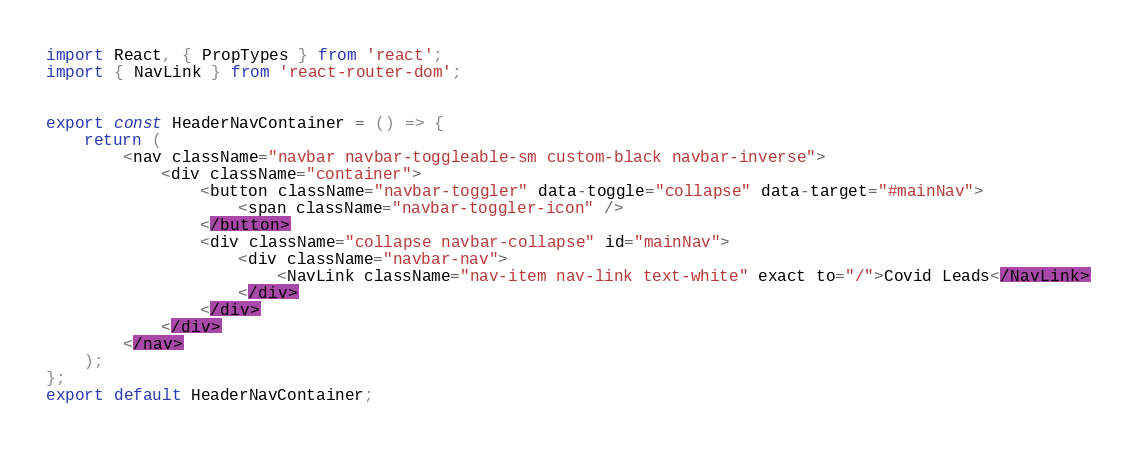Convert code to text. <code><loc_0><loc_0><loc_500><loc_500><_JavaScript_>import React, { PropTypes } from 'react';
import { NavLink } from 'react-router-dom';


export const HeaderNavContainer = () => {
    return (
        <nav className="navbar navbar-toggleable-sm custom-black navbar-inverse">
            <div className="container">
                <button className="navbar-toggler" data-toggle="collapse" data-target="#mainNav">
                    <span className="navbar-toggler-icon" />
                </button>
                <div className="collapse navbar-collapse" id="mainNav">
                    <div className="navbar-nav">
                        <NavLink className="nav-item nav-link text-white" exact to="/">Covid Leads</NavLink>
                    </div>
                </div>
            </div>
        </nav>
    );
};
export default HeaderNavContainer;

</code> 